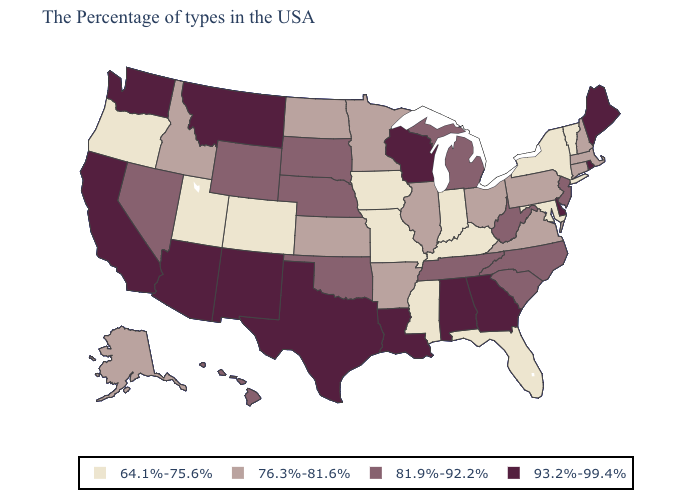Among the states that border Michigan , does Indiana have the lowest value?
Quick response, please. Yes. Name the states that have a value in the range 81.9%-92.2%?
Answer briefly. New Jersey, North Carolina, South Carolina, West Virginia, Michigan, Tennessee, Nebraska, Oklahoma, South Dakota, Wyoming, Nevada, Hawaii. What is the value of Arizona?
Quick response, please. 93.2%-99.4%. Name the states that have a value in the range 81.9%-92.2%?
Write a very short answer. New Jersey, North Carolina, South Carolina, West Virginia, Michigan, Tennessee, Nebraska, Oklahoma, South Dakota, Wyoming, Nevada, Hawaii. What is the lowest value in states that border Louisiana?
Quick response, please. 64.1%-75.6%. What is the highest value in the MidWest ?
Write a very short answer. 93.2%-99.4%. Does Iowa have the highest value in the USA?
Answer briefly. No. What is the highest value in states that border Missouri?
Quick response, please. 81.9%-92.2%. What is the value of Montana?
Write a very short answer. 93.2%-99.4%. Name the states that have a value in the range 81.9%-92.2%?
Answer briefly. New Jersey, North Carolina, South Carolina, West Virginia, Michigan, Tennessee, Nebraska, Oklahoma, South Dakota, Wyoming, Nevada, Hawaii. What is the lowest value in the MidWest?
Concise answer only. 64.1%-75.6%. What is the lowest value in states that border Washington?
Write a very short answer. 64.1%-75.6%. What is the value of Illinois?
Quick response, please. 76.3%-81.6%. Name the states that have a value in the range 76.3%-81.6%?
Concise answer only. Massachusetts, New Hampshire, Connecticut, Pennsylvania, Virginia, Ohio, Illinois, Arkansas, Minnesota, Kansas, North Dakota, Idaho, Alaska. 